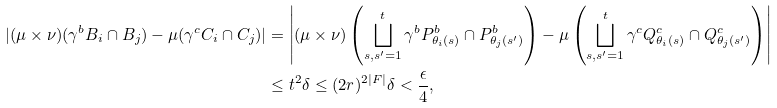<formula> <loc_0><loc_0><loc_500><loc_500>| ( \mu \times \nu ) ( \gamma ^ { b } B _ { i } \cap B _ { j } ) - \mu ( \gamma ^ { c } C _ { i } \cap C _ { j } ) | & = \left | ( \mu \times \nu ) \left ( \bigsqcup _ { s , s ^ { \prime } = 1 } ^ { t } \gamma ^ { b } P ^ { b } _ { \theta _ { i } ( s ) } \cap P ^ { b } _ { \theta _ { j } ( s ^ { \prime } ) } \right ) - \mu \left ( \bigsqcup _ { s , s ^ { \prime } = 1 } ^ { t } \gamma ^ { c } Q ^ { c } _ { \theta _ { i } ( s ) } \cap Q ^ { c } _ { \theta _ { j } ( s ^ { \prime } ) } \right ) \right | \\ & \leq t ^ { 2 } \delta \leq ( 2 r ) ^ { 2 | F | } \delta < \frac { \epsilon } { 4 } ,</formula> 